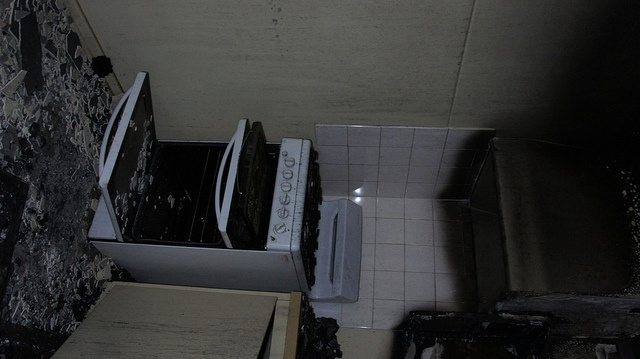Describe the objects in this image and their specific colors. I can see a oven in black and gray tones in this image. 